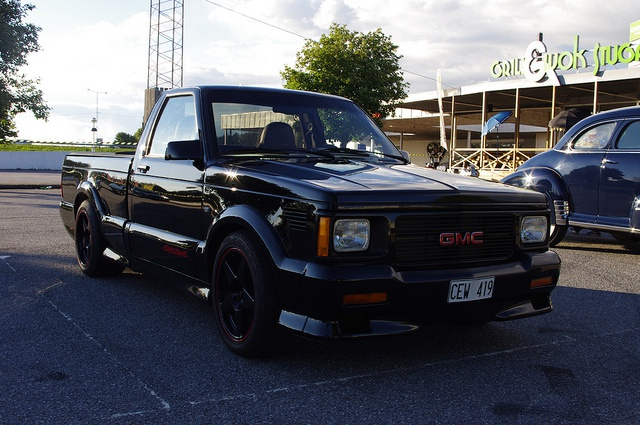Describe the objects in this image and their specific colors. I can see truck in black, gray, navy, and lightgray tones, car in black, navy, blue, and gray tones, umbrella in black, lightblue, blue, navy, and darkgray tones, and umbrella in black and gray tones in this image. 